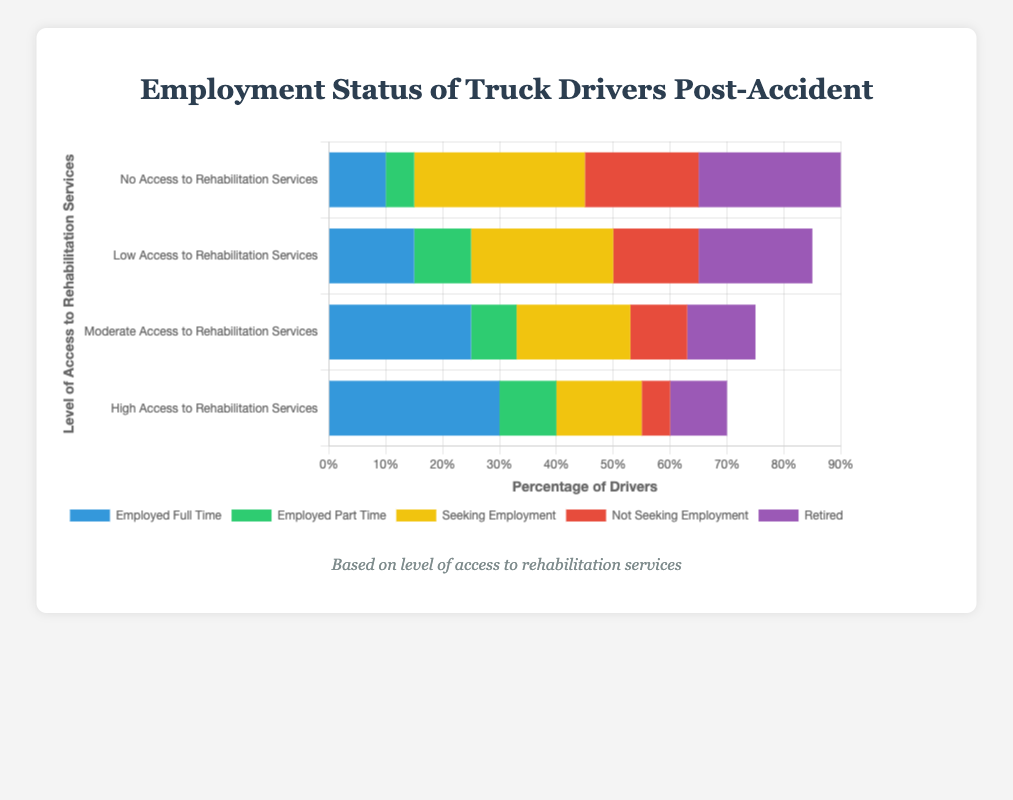Which group has the highest percentage of retired drivers? By referring to the figure, look for the group with the tallest bar section colored in purple (retired). The "No Access to Rehabilitation Services" group has the highest percentage of retired drivers at 25%.
Answer: No Access to Rehabilitation Services Which group has the most full-time employed drivers? By referring to the figure, look for the group with the tallest bar section colored in blue (employed full time). The "High Access to Rehabilitation Services" group has the most full-time employed drivers at 30%.
Answer: High Access to Rehabilitation Services What is the total percentage of drivers seeking or not seeking employment in the group with low access to rehabilitation services? Sum up the height of the yellow bar (seeking employment) and the red bar (not seeking employment) for the "Low Access to Rehabilitation Services" group. Seeking employment is 25% and not seeking employment is 15%, so the total is 25% + 15% = 40%.
Answer: 40% Which group has the lowest percentage of part-time employed drivers? By referring to the figure, look for the group with the shortest bar section colored in green (employed part time). The "No Access to Rehabilitation Services" group has the lowest percentage of part-time employed drivers at 5%.
Answer: No Access to Rehabilitation Services 